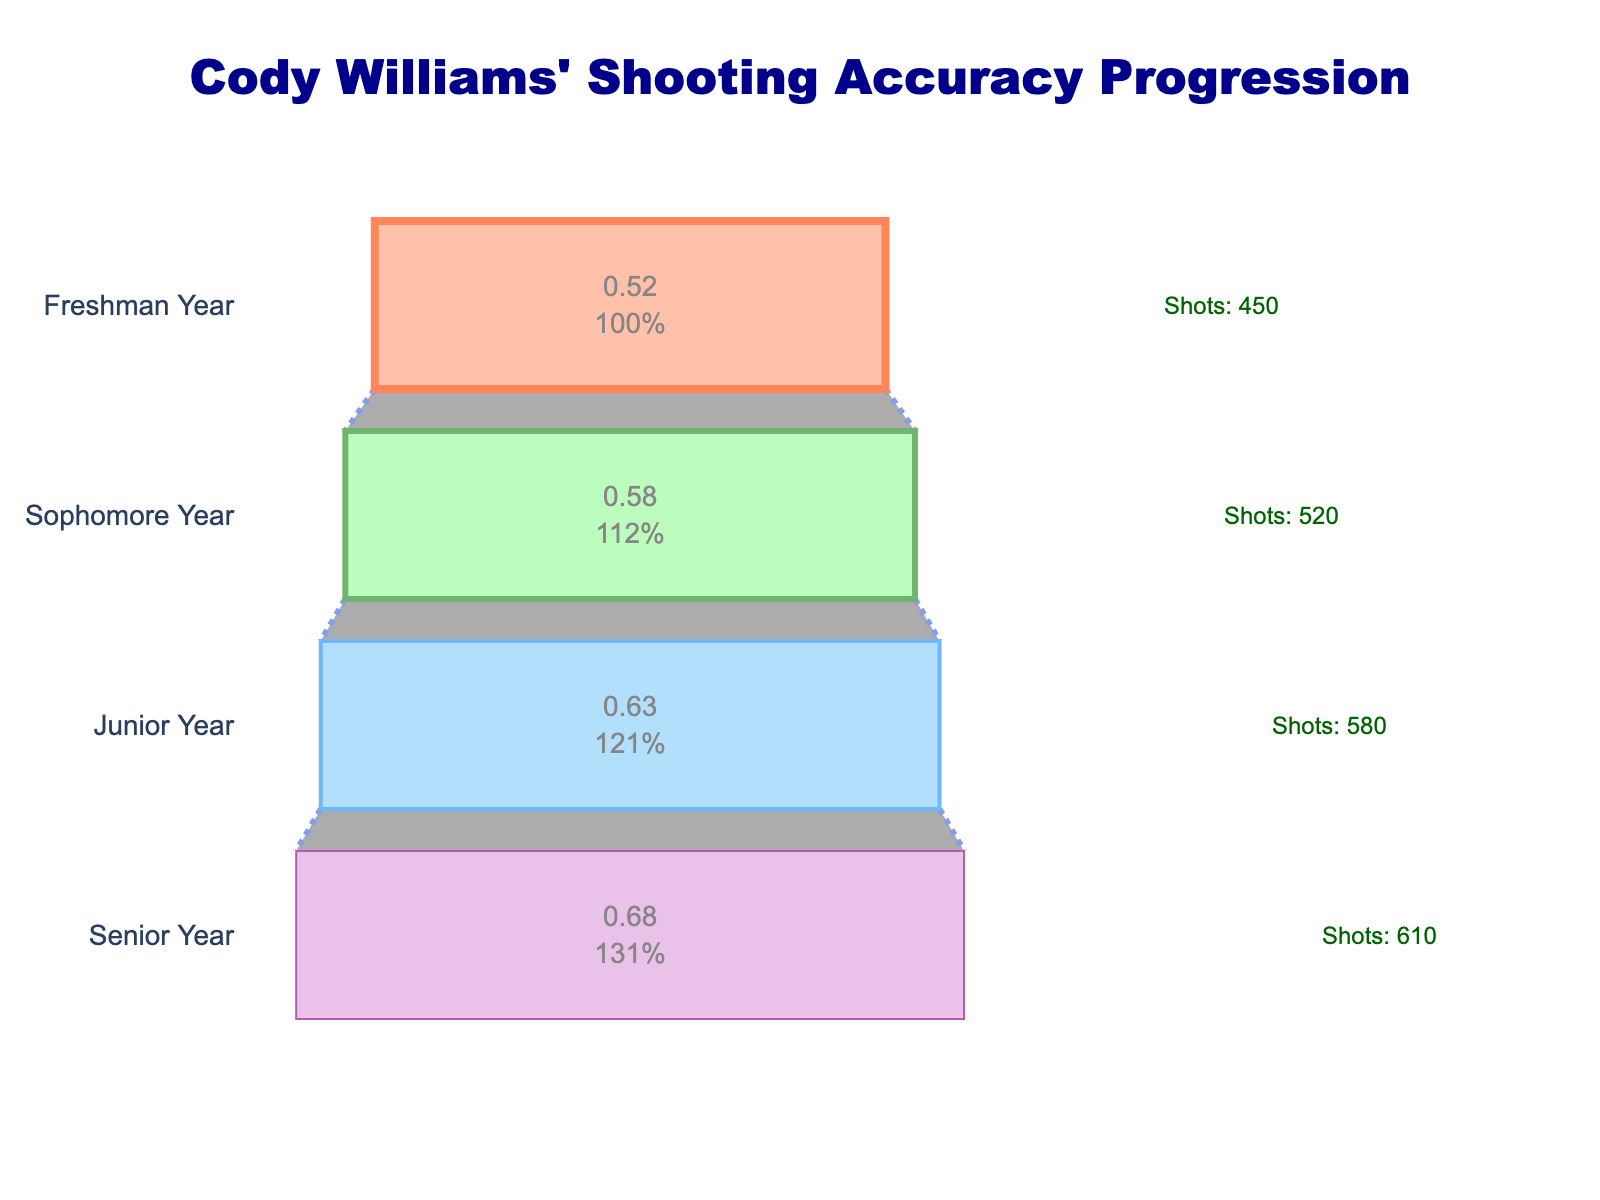What is the title of the chart? The title is the main text at the top of the chart which usually provides a summary of the data being displayed.
Answer: Cody Williams' Shooting Accuracy Progression How many stages of shooting accuracy are shown in the chart? Count the distinct stages labeled in the funnel chart which represent Cody Williams' different years in high school.
Answer: 4 What is the accuracy percentage in Cody's sophomore year? Look for the label that says "Sophomore Year" and read the value next to it in the funnel chart.
Answer: 58% How does Cody's accuracy in his senior year compare to his junior year in percentage points? Subtract the junior year accuracy percentage from the senior year accuracy percentage. 68% - 63%
Answer: 5% What is the color of the funnel section for Cody's freshman year? Look at the color filling the section labeled "Freshman Year".
Answer: Light salmon Which year did Cody attempt the most shots? Look at the annotations next to each stage that indicates "Shots:". Compare the number of shots attempted for each year.
Answer: Senior Year What is the overall increase in Cody's shooting accuracy from his freshman to senior year? Subtract the freshman year accuracy percentage from the senior year accuracy percentage. 68% - 52%
Answer: 16% Is the connector line style between the stages solid or dashed? Observe the visual appearance of the line connecting the funnel sections.
Answer: Dashed What is the difference in shots attempted between Cody’s junior and freshman years? Subtract the number of shots attempted in the freshman year from those in the junior year. 580 - 450
Answer: 130 What is the average shooting accuracy over Cody's high school career as shown in the chart? Add the accuracy percentages for all four years and then divide by the number of years. (52% + 58% + 63% + 68%) / 4 = 241% / 4
Answer: 60.25% 